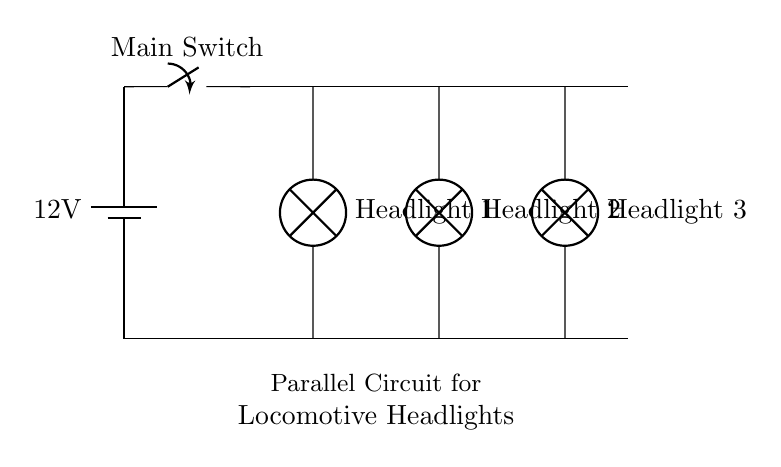What is the voltage supply in this circuit? The diagram indicates a battery supplying a voltage of 12 volts, as labeled on the battery symbol.
Answer: 12 volts What type of circuit is shown in this diagram? The circuit consists of multiple components connected in parallel, as evidenced by the branches leading to the headlights, indicating that each component operates independently.
Answer: Parallel How many headlights are in the circuit? There are three distinct branch paths in the diagram, each leading to a headlight, which can be counted from the connections depicted.
Answer: Three What is the purpose of the main switch in this circuit? The main switch controls the flow of current from the battery to the rest of the circuit. When closed, it allows current to flow, illuminating the headlights; when open, it disconnects the headlights from the power source.
Answer: To control current flow If one headlight fails, what happens to the others? The circuit is designed in parallel, meaning that each headlight operates independently; therefore, if one fails, the others remain illuminated due to the continued flow of current through their respective branches.
Answer: Others remain illuminated What are the components shown in this circuit? The components include a battery, a switch, and three lamps (headlights), which are clearly labeled in the diagram.
Answer: Battery, switch, lamps 